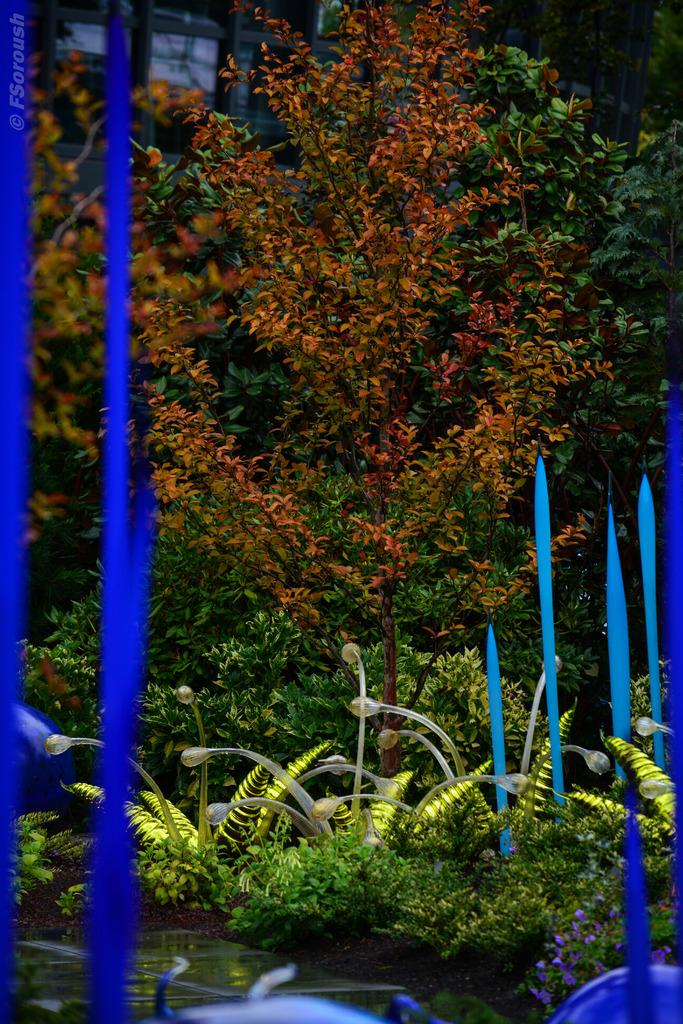What is the primary element visible in the image? There is water in the image. What types of vegetation can be seen in the image? There are plants, flowers, and trees in the image. What is the distance between the egg and the room in the image? There is no egg or room present in the image. 